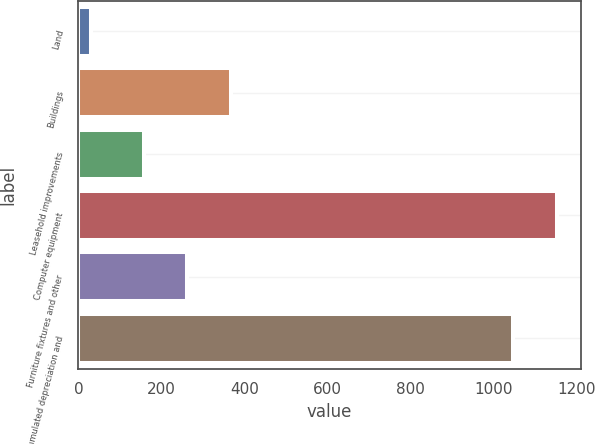Convert chart. <chart><loc_0><loc_0><loc_500><loc_500><bar_chart><fcel>Land<fcel>Buildings<fcel>Leasehold improvements<fcel>Computer equipment<fcel>Furniture fixtures and other<fcel>Accumulated depreciation and<nl><fcel>31<fcel>366.4<fcel>158<fcel>1151.2<fcel>262.2<fcel>1047<nl></chart> 